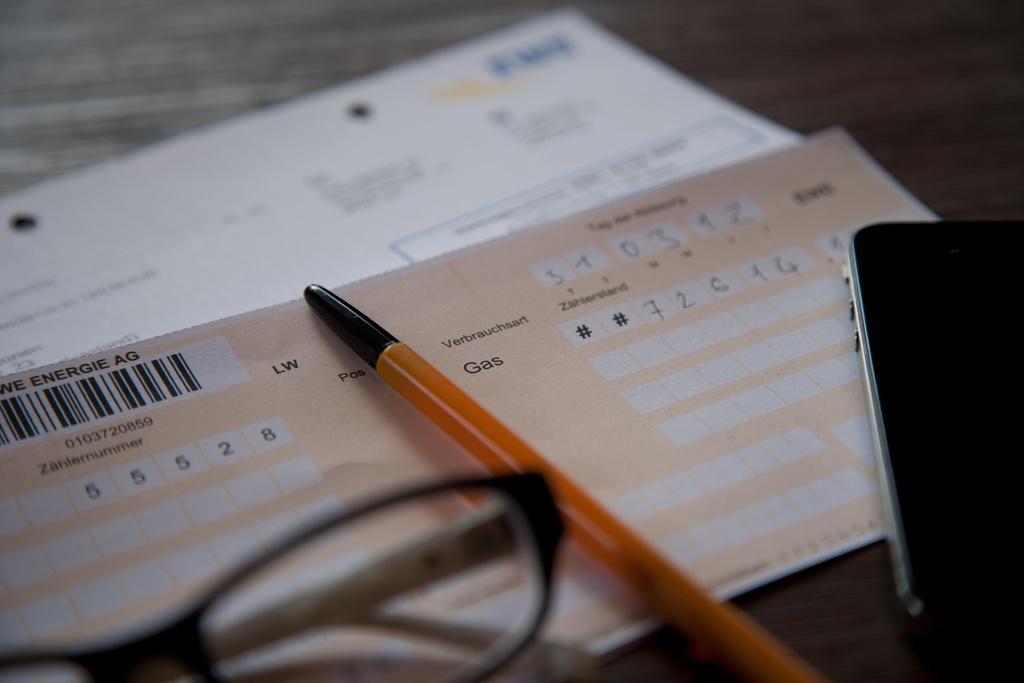What three letter word is to the right of the pen?
Your response must be concise. Gas. What numbers are on the left of the pencil?
Offer a very short reply. 55528. 